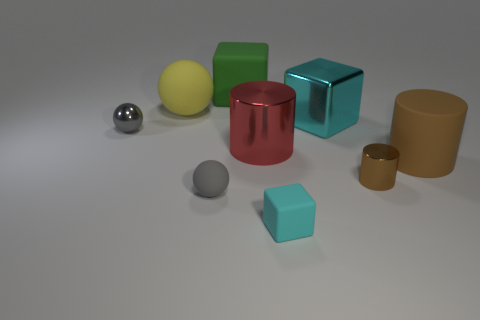Do the materials of the objects offer any clues about their possible uses or what they represent? The variety of materials, such as matte, metallic, and smooth surfaces, may suggest they're illustrative models used to demonstrate how different textures interact with light, possibly for educational or design purposes. 